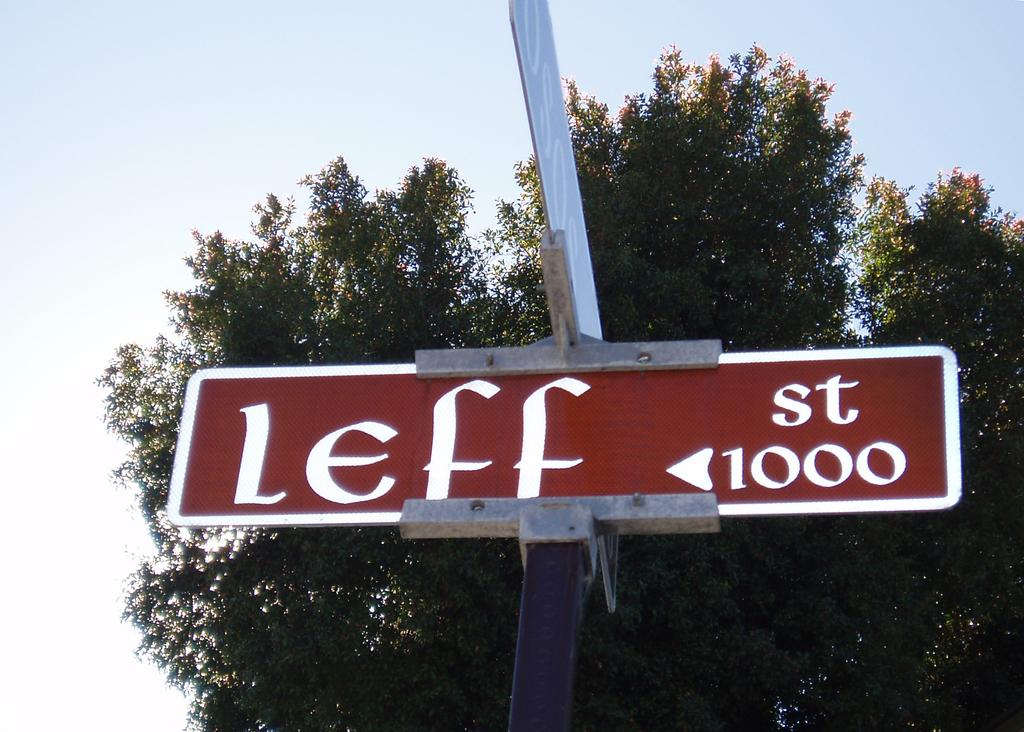What is located in the foreground of the image? There is a sign board in the foreground of the image. What can be seen in the background of the image? There is a tree and the sky visible in the background of the image. What type of tin can be seen hanging from the tree in the image? There is no tin present in the image, and the tree does not have anything hanging from it. 